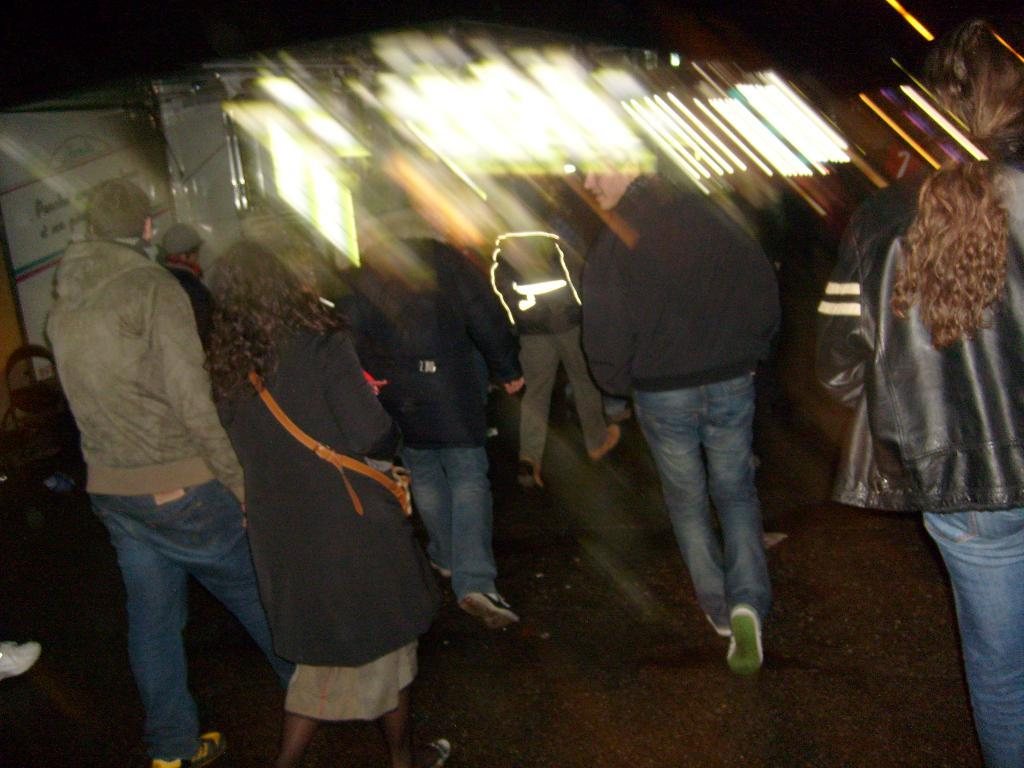What is present in the image? There are people in the image. What are the people doing in the image? The people are walking on the road. Can you describe the background of the image? The background of the image is blurred. Where is the scarecrow located in the image? There is no scarecrow present in the image. What type of crate is being carried by the children in the image? There are no children or crates present in the image. 